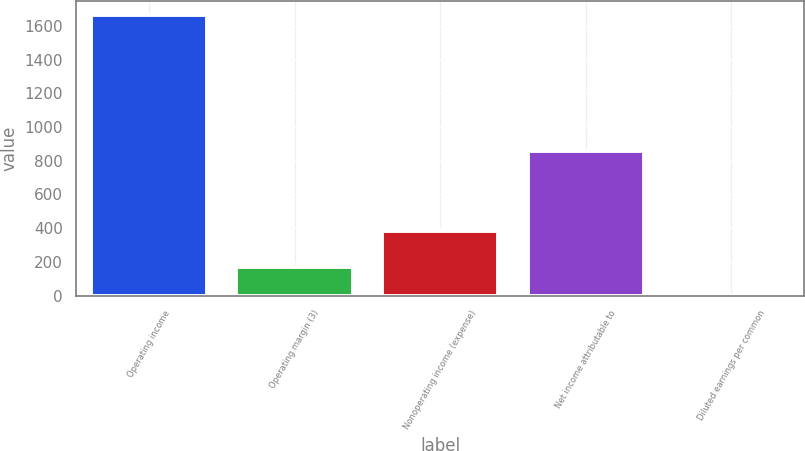Convert chart to OTSL. <chart><loc_0><loc_0><loc_500><loc_500><bar_chart><fcel>Operating income<fcel>Operating margin (3)<fcel>Nonoperating income (expense)<fcel>Net income attributable to<fcel>Diluted earnings per common<nl><fcel>1662<fcel>171.87<fcel>384<fcel>856<fcel>6.3<nl></chart> 